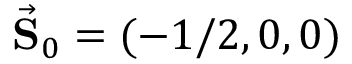Convert formula to latex. <formula><loc_0><loc_0><loc_500><loc_500>\vec { S } _ { 0 } = ( - 1 / 2 , 0 , 0 )</formula> 